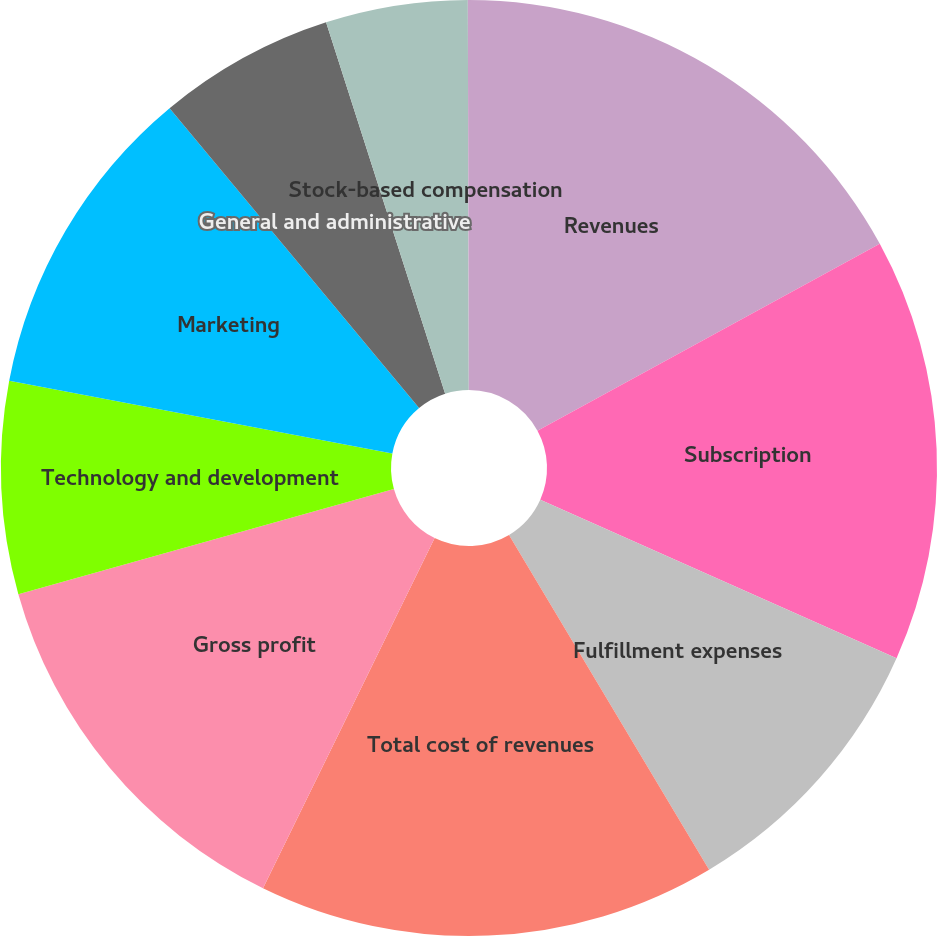<chart> <loc_0><loc_0><loc_500><loc_500><pie_chart><fcel>Revenues<fcel>Subscription<fcel>Fulfillment expenses<fcel>Total cost of revenues<fcel>Gross profit<fcel>Technology and development<fcel>Marketing<fcel>General and administrative<fcel>Stock-based compensation<fcel>Gain on disposal of DVDs<nl><fcel>17.05%<fcel>14.62%<fcel>9.76%<fcel>15.83%<fcel>13.4%<fcel>7.33%<fcel>10.97%<fcel>6.11%<fcel>4.9%<fcel>0.04%<nl></chart> 